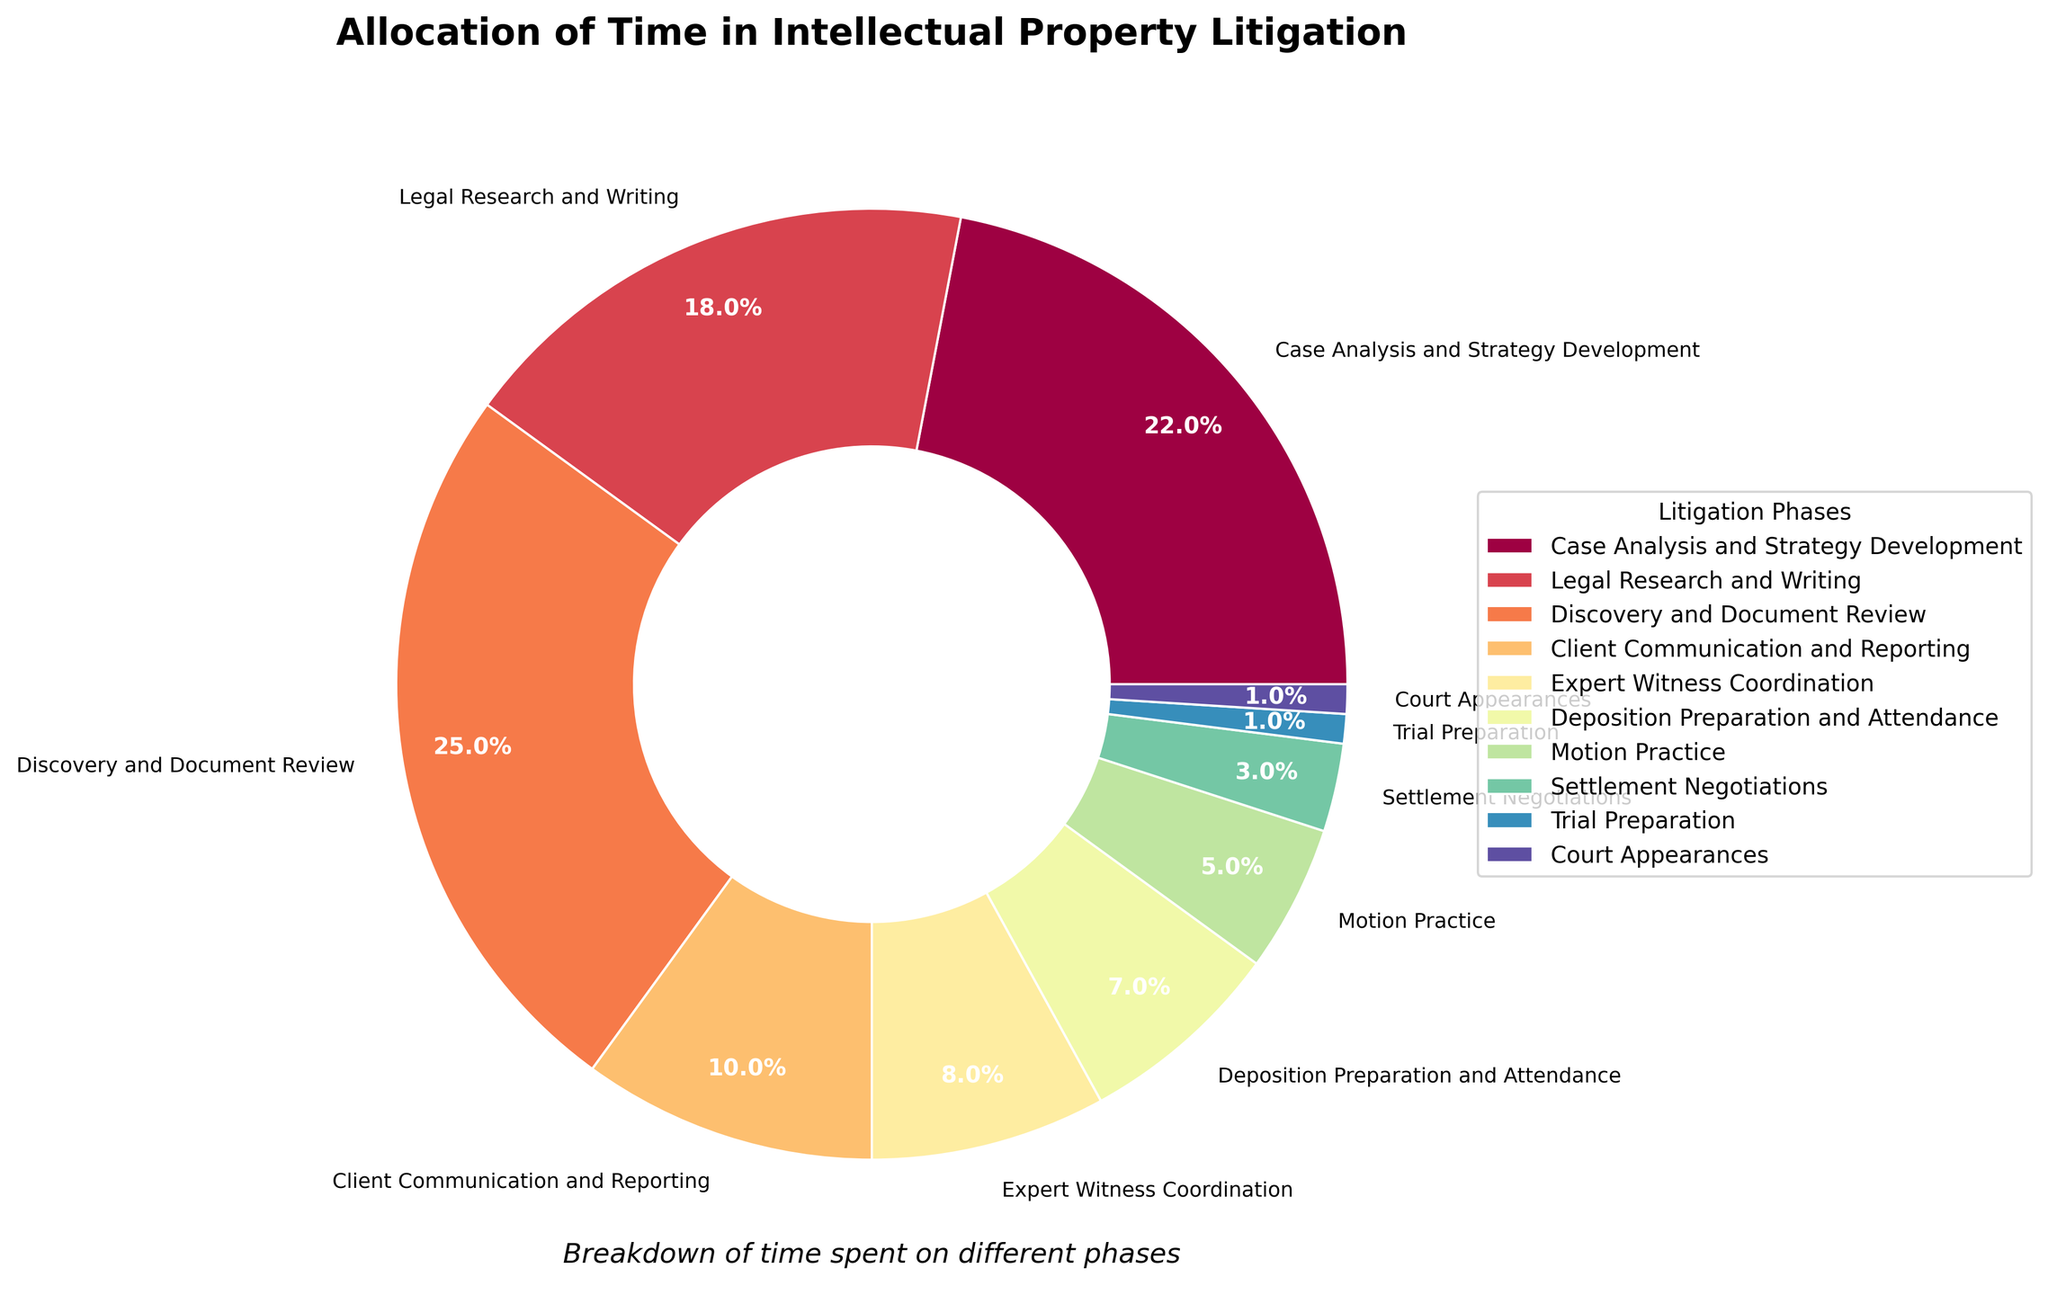What phase takes up the largest percentage of time? By visually inspecting the slices of the pie chart, it's clear that "Discovery and Document Review" segment is the largest, indicating it has the highest percentage.
Answer: Discovery and Document Review Which phase takes up more time: Legal Research and Writing or Deposition Preparation and Attendance? We compare the size of the slices and find that "Legal Research and Writing" has a larger segment at 18%, while "Deposition Preparation and Attendance" has 7%.
Answer: Legal Research and Writing What is the combined percentage of time spent on Trial Preparation and Court Appearances? Adding the percentages of "Trial Preparation" (1%) and "Court Appearances" (1%), we get 1% + 1% = 2%.
Answer: 2% How much more time is allocated to Client Communication and Reporting compared to Expert Witness Coordination? Comparing the slices, "Client Communication and Reporting" is at 10%, and "Expert Witness Coordination" is at 8%. The difference is 10% - 8% = 2%.
Answer: 2% Does the percentage of time spent on Settlement Negotiations and Motion Practice combined exceed 10%? Adding the percentages for "Settlement Negotiations" (3%) and "Motion Practice" (5%), we get 3% + 5% = 8%, which is less than 10%.
Answer: No Which tasks have a percentage allocation of less than 5% each? By examining the segments, we see that "Settlement Negotiations" (3%), "Trial Preparation" (1%), and "Court Appearances" (1%) each have less than 5%.
Answer: Settlement Negotiations, Trial Preparation, Court Appearances What proportion of the total time is taken up by both Case Analysis and Strategy Development and Discovery and Document Review? Adding the percentages of "Case Analysis and Strategy Development" (22%) and "Discovery and Document Review" (25%), we get 22% + 25% = 47%.
Answer: 47% Ratio of the time spent on Legal Research and Writing to that on Expert Witness Coordination? The percentage for "Legal Research and Writing" is 18% and for "Expert Witness Coordination" is 8%. The ratio is 18 / 8 = 2.25.
Answer: 2.25 Which has a smaller percentage allocation: Motion Practice or Deposition Preparation and Attendance? The "Motion Practice" segment (5%) is smaller compared to "Deposition Preparation and Attendance" (7%).
Answer: Motion Practice What is the average percentage allocation for the phases related to client interactions (Client Communication and Reporting, Settlement Negotiations)? Calculate the average for "Client Communication and Reporting" (10%) and "Settlement Negotiations" (3%): (10 + 3) / 2 = 6.5%.
Answer: 6.5% 